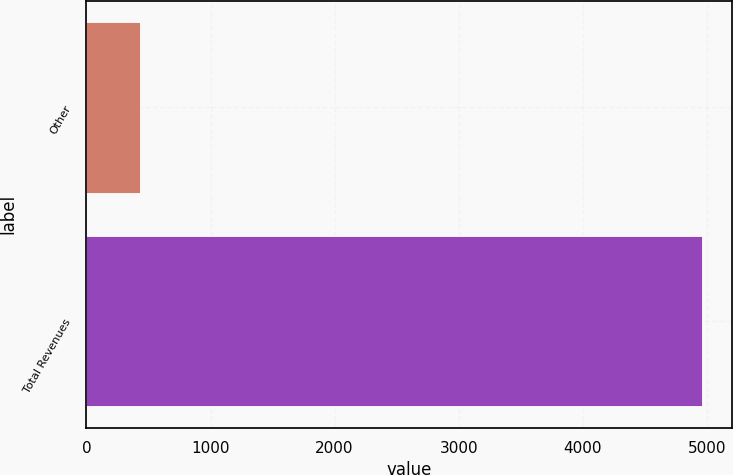Convert chart. <chart><loc_0><loc_0><loc_500><loc_500><bar_chart><fcel>Other<fcel>Total Revenues<nl><fcel>428<fcel>4956<nl></chart> 